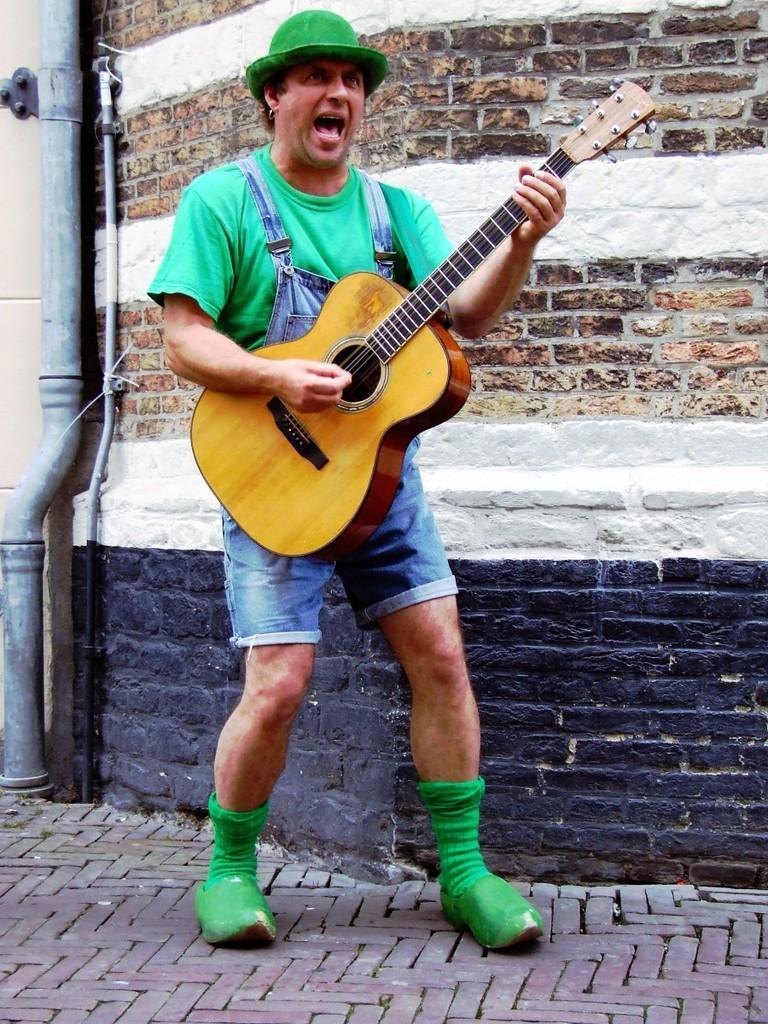How would you summarize this image in a sentence or two? Here we can see a person standing and playing a guitar and singing a song and behind him we can see pipe and he is wearing a hat 